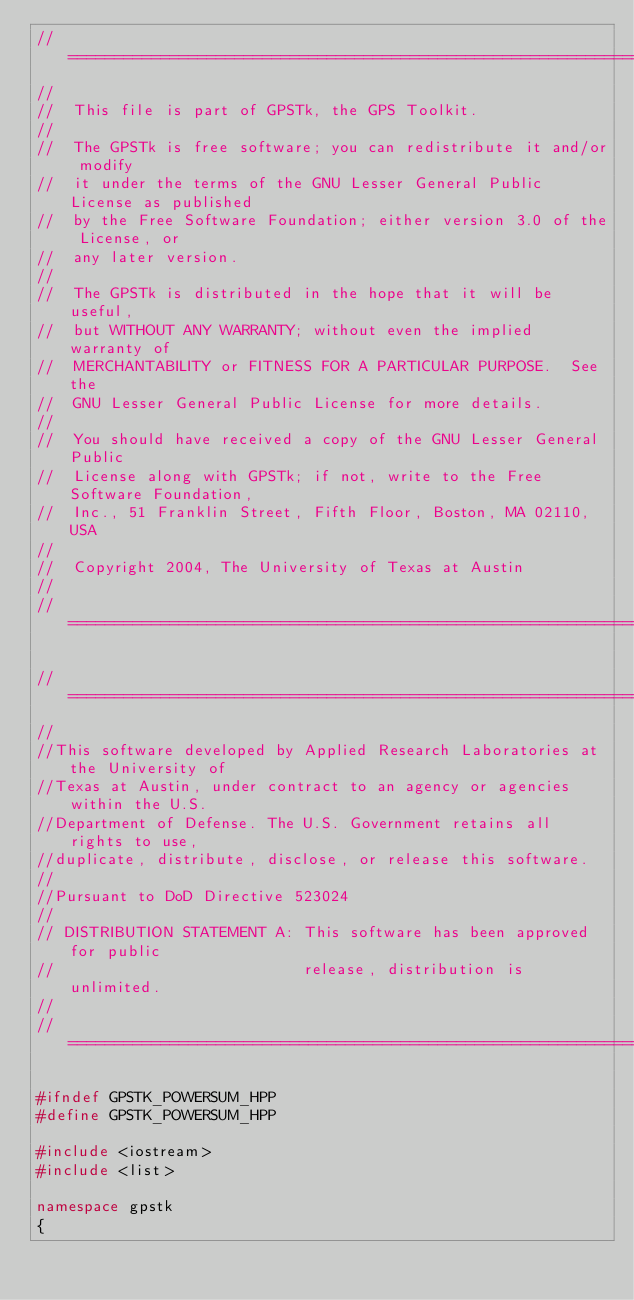Convert code to text. <code><loc_0><loc_0><loc_500><loc_500><_C++_>//============================================================================
//
//  This file is part of GPSTk, the GPS Toolkit.
//
//  The GPSTk is free software; you can redistribute it and/or modify
//  it under the terms of the GNU Lesser General Public License as published
//  by the Free Software Foundation; either version 3.0 of the License, or
//  any later version.
//
//  The GPSTk is distributed in the hope that it will be useful,
//  but WITHOUT ANY WARRANTY; without even the implied warranty of
//  MERCHANTABILITY or FITNESS FOR A PARTICULAR PURPOSE.  See the
//  GNU Lesser General Public License for more details.
//
//  You should have received a copy of the GNU Lesser General Public
//  License along with GPSTk; if not, write to the Free Software Foundation,
//  Inc., 51 Franklin Street, Fifth Floor, Boston, MA 02110, USA
//  
//  Copyright 2004, The University of Texas at Austin
//
//============================================================================

//============================================================================
//
//This software developed by Applied Research Laboratories at the University of
//Texas at Austin, under contract to an agency or agencies within the U.S. 
//Department of Defense. The U.S. Government retains all rights to use,
//duplicate, distribute, disclose, or release this software. 
//
//Pursuant to DoD Directive 523024 
//
// DISTRIBUTION STATEMENT A: This software has been approved for public 
//                           release, distribution is unlimited.
//
//=============================================================================

#ifndef GPSTK_POWERSUM_HPP
#define GPSTK_POWERSUM_HPP

#include <iostream>
#include <list>

namespace gpstk
{</code> 